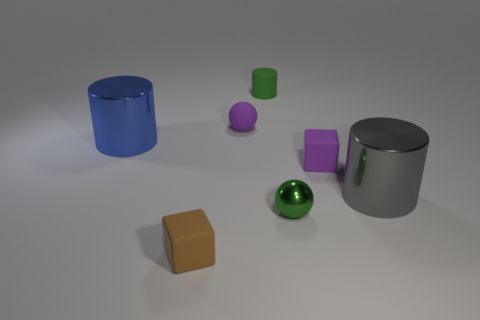Add 2 purple blocks. How many objects exist? 9 Subtract all spheres. How many objects are left? 5 Subtract 0 brown spheres. How many objects are left? 7 Subtract all big gray metallic cylinders. Subtract all tiny brown blocks. How many objects are left? 5 Add 2 green cylinders. How many green cylinders are left? 3 Add 1 tiny blue metallic things. How many tiny blue metallic things exist? 1 